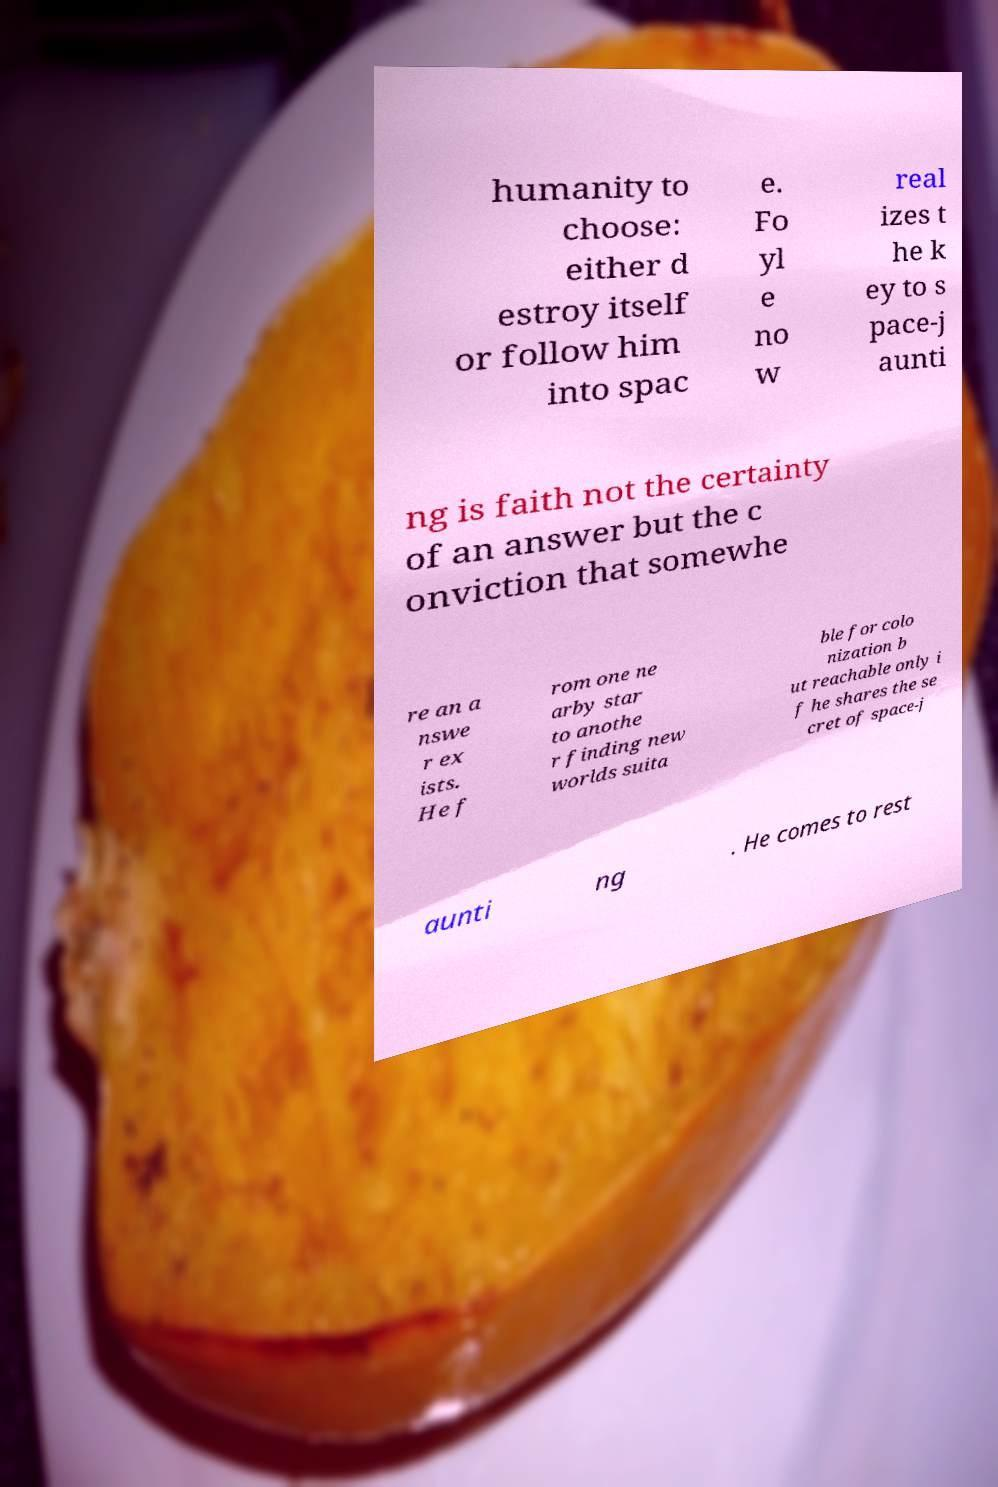There's text embedded in this image that I need extracted. Can you transcribe it verbatim? humanity to choose: either d estroy itself or follow him into spac e. Fo yl e no w real izes t he k ey to s pace-j aunti ng is faith not the certainty of an answer but the c onviction that somewhe re an a nswe r ex ists. He f rom one ne arby star to anothe r finding new worlds suita ble for colo nization b ut reachable only i f he shares the se cret of space-j aunti ng . He comes to rest 